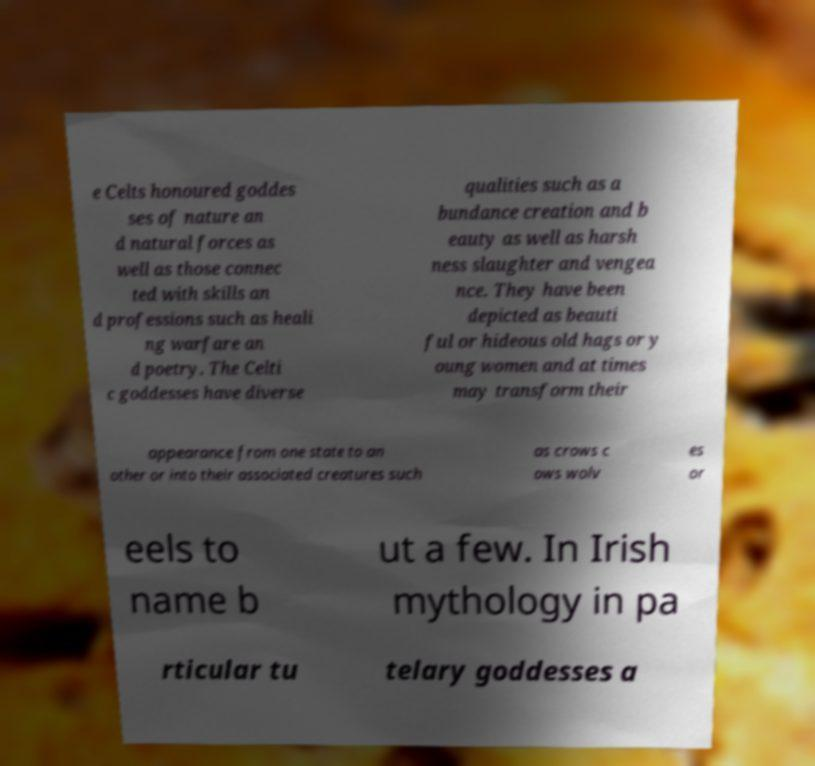Could you extract and type out the text from this image? e Celts honoured goddes ses of nature an d natural forces as well as those connec ted with skills an d professions such as heali ng warfare an d poetry. The Celti c goddesses have diverse qualities such as a bundance creation and b eauty as well as harsh ness slaughter and vengea nce. They have been depicted as beauti ful or hideous old hags or y oung women and at times may transform their appearance from one state to an other or into their associated creatures such as crows c ows wolv es or eels to name b ut a few. In Irish mythology in pa rticular tu telary goddesses a 